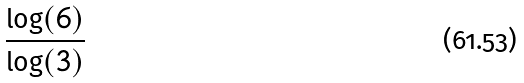<formula> <loc_0><loc_0><loc_500><loc_500>\frac { \log ( 6 ) } { \log ( 3 ) }</formula> 